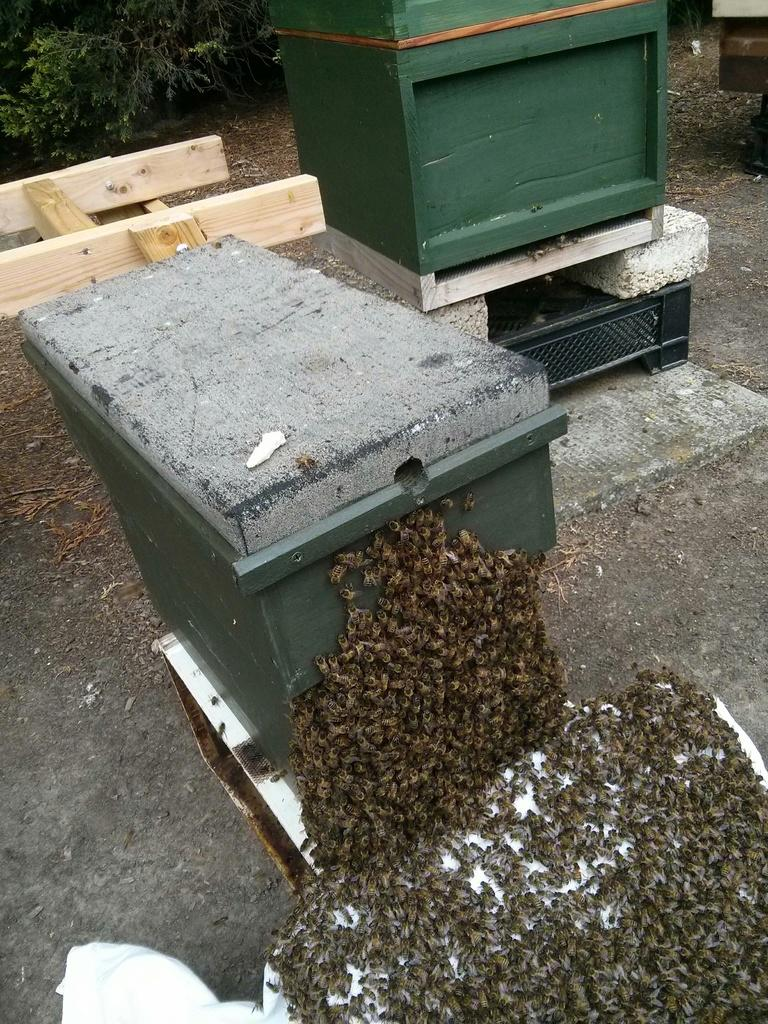What type of objects are in the image? There are wooden boxes in the image. What living creatures can be seen in the image? There are bees in the image. What type of furniture is visible in the background of the image? There is a bench in the background of the image. What type of plant is visible in the background of the image? There is a tree in the background of the image. What is the fact about the harmony between the wooden boxes and the bees in the image? There is no information about harmony between the wooden boxes and the bees in the image, as the facts provided do not mention any interaction or relationship between these subjects. 